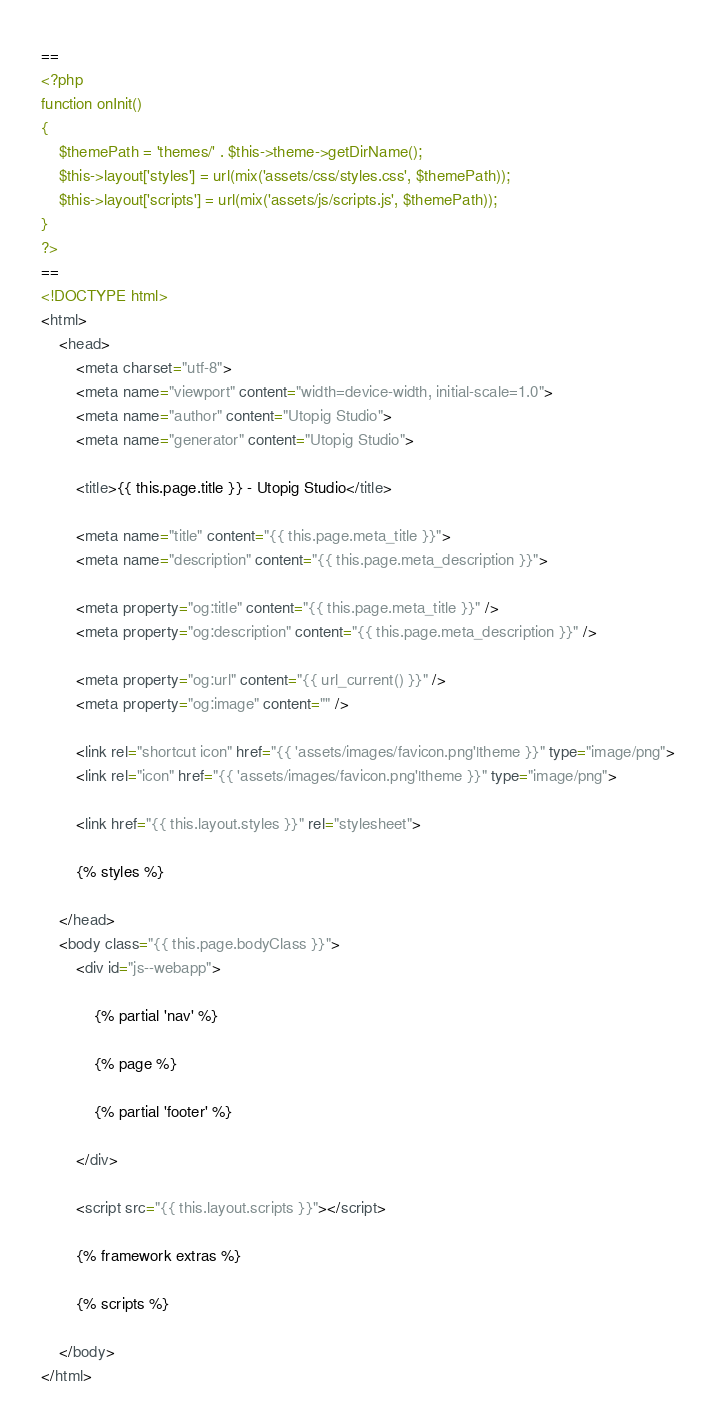<code> <loc_0><loc_0><loc_500><loc_500><_HTML_>==
<?php
function onInit()
{
    $themePath = 'themes/' . $this->theme->getDirName();
    $this->layout['styles'] = url(mix('assets/css/styles.css', $themePath));
    $this->layout['scripts'] = url(mix('assets/js/scripts.js', $themePath));
}
?>
==
<!DOCTYPE html>
<html>
    <head>
        <meta charset="utf-8">
        <meta name="viewport" content="width=device-width, initial-scale=1.0">
        <meta name="author" content="Utopig Studio">
        <meta name="generator" content="Utopig Studio">

        <title>{{ this.page.title }} - Utopig Studio</title>

        <meta name="title" content="{{ this.page.meta_title }}">
        <meta name="description" content="{{ this.page.meta_description }}">

        <meta property="og:title" content="{{ this.page.meta_title }}" />
        <meta property="og:description" content="{{ this.page.meta_description }}" />

        <meta property="og:url" content="{{ url_current() }}" />
        <meta property="og:image" content="" />

        <link rel="shortcut icon" href="{{ 'assets/images/favicon.png'|theme }}" type="image/png">
        <link rel="icon" href="{{ 'assets/images/favicon.png'|theme }}" type="image/png">

        <link href="{{ this.layout.styles }}" rel="stylesheet">

        {% styles %}

    </head>
    <body class="{{ this.page.bodyClass }}">
        <div id="js--webapp">

            {% partial 'nav' %}

            {% page %}

            {% partial 'footer' %}

        </div>

        <script src="{{ this.layout.scripts }}"></script>

        {% framework extras %}
    
        {% scripts %}

    </body>
</html>
</code> 